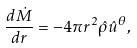<formula> <loc_0><loc_0><loc_500><loc_500>\frac { d \dot { M } } { d r } = - 4 \pi r ^ { 2 } \hat { \rho } \hat { u } ^ { \theta } ,</formula> 